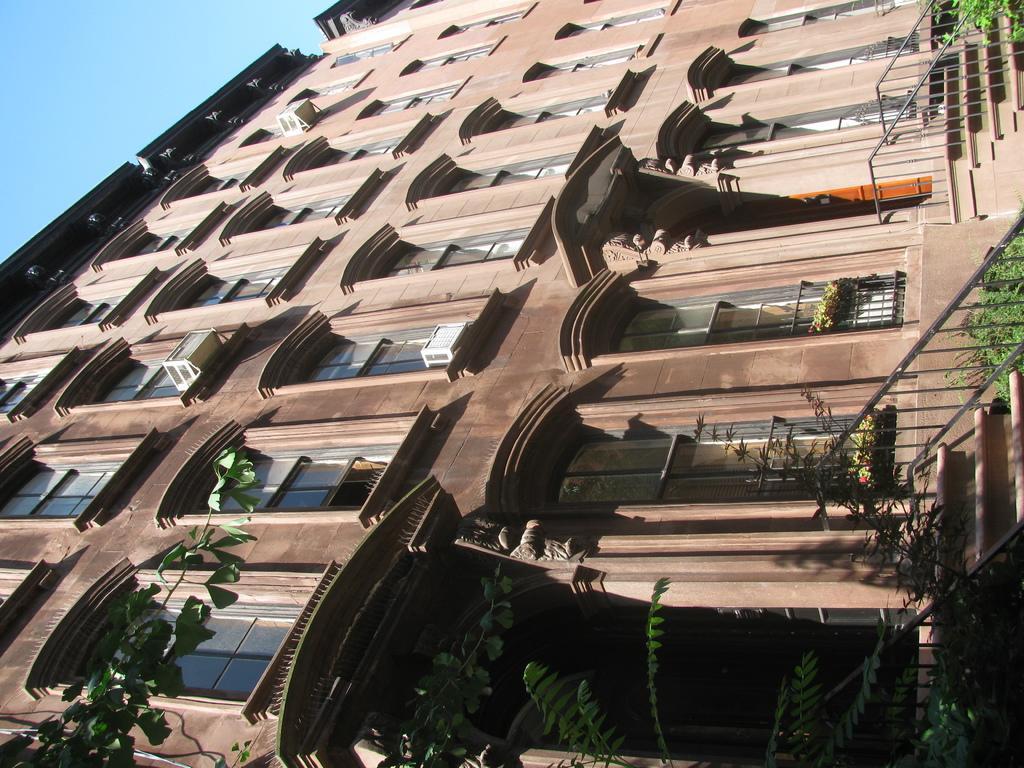How would you summarize this image in a sentence or two? This image is rotated. In this image we can see there is a building, in front of the building there are stairs and railing, beside the stairs there are plants. On the top left side of the image there is a sky. 